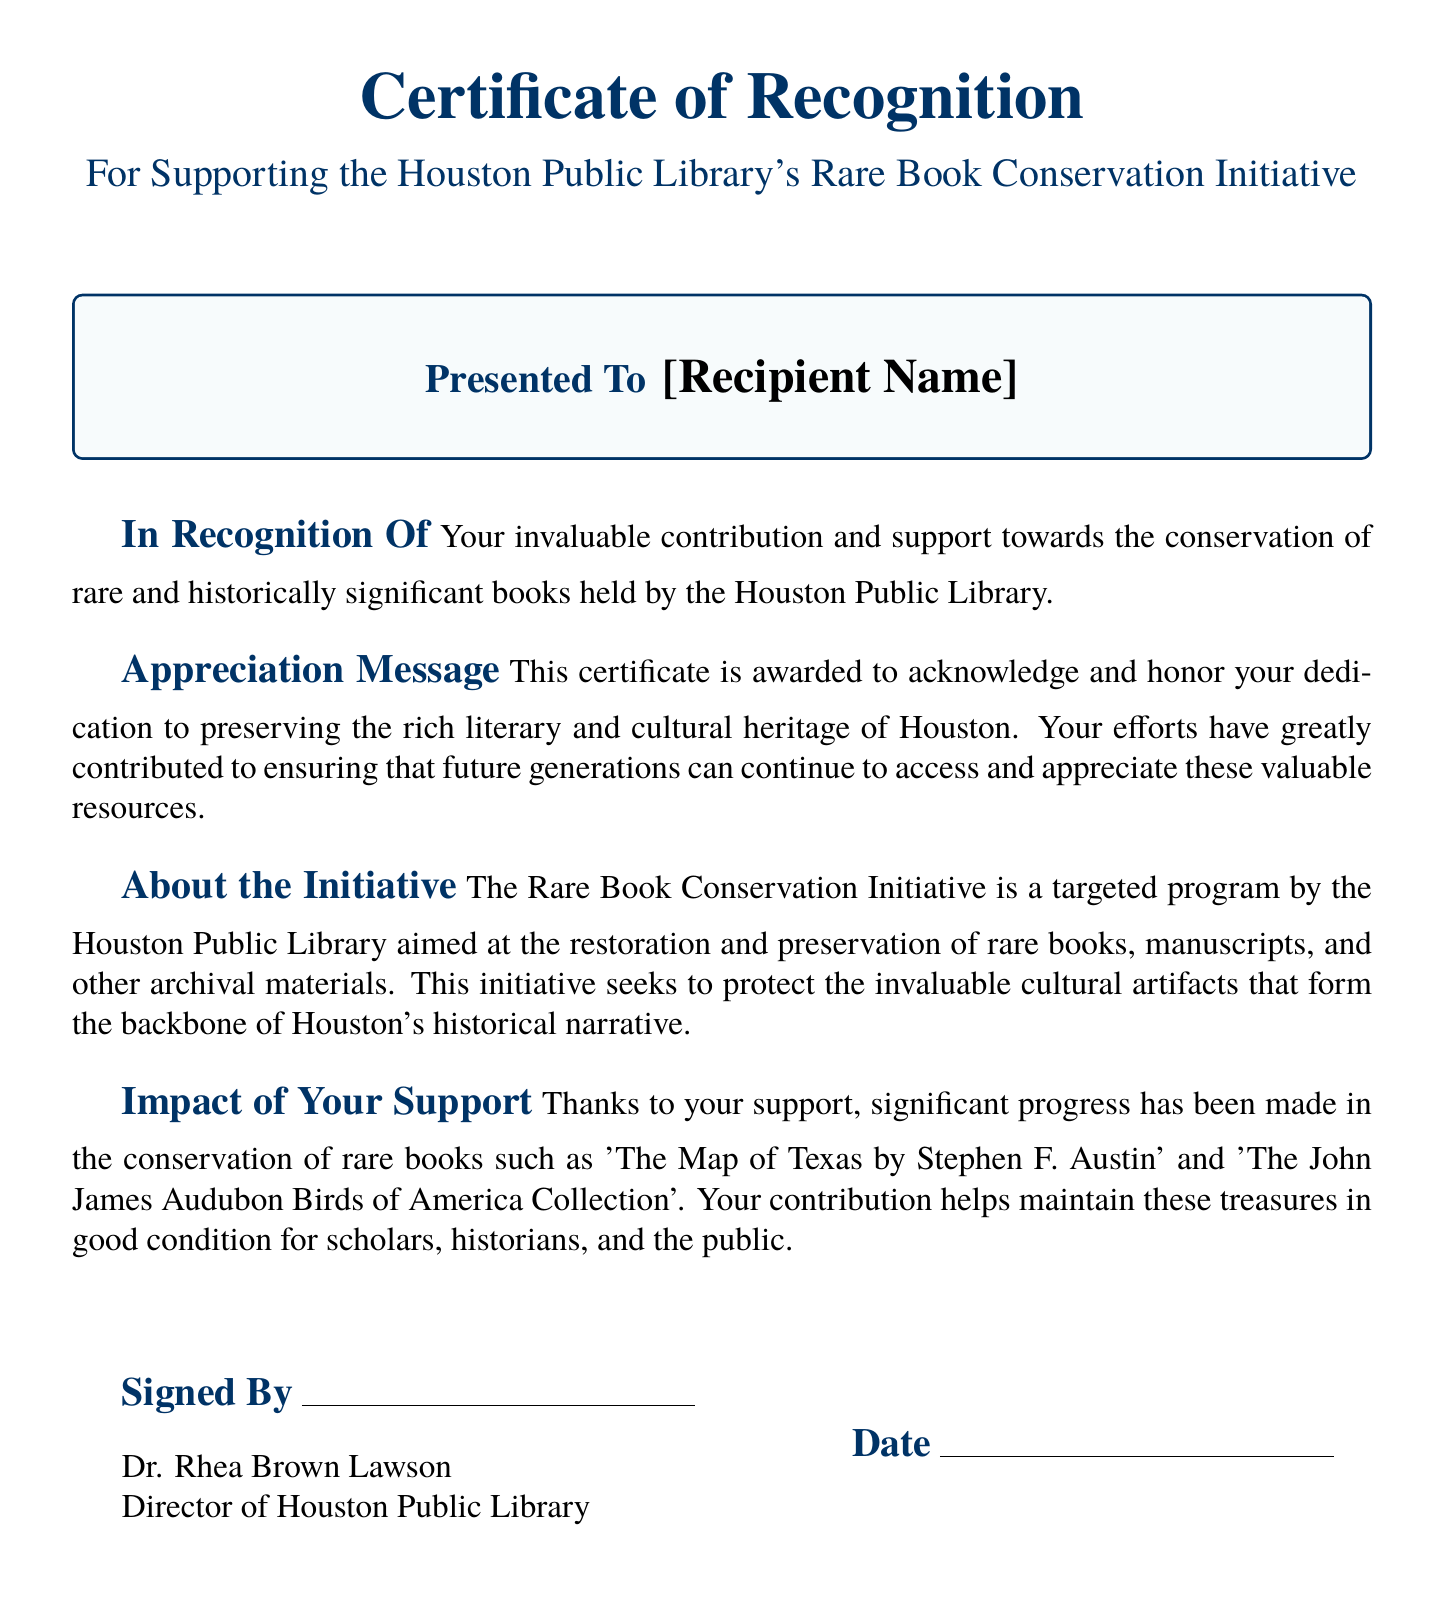what is the title of the certificate? The title of the certificate is specified in the header section of the document.
Answer: Certificate of Recognition who is the recipient of the certificate? The recipient's name is indicated within the box that is labeled "Presented To".
Answer: [Recipient Name] who signed the certificate? The signature section of the certificate names the individual who signed it.
Answer: Dr. Rhea Brown Lawson what is the purpose of the Rare Book Conservation Initiative? The purpose is described in the section titled "About the Initiative".
Answer: Restoration and preservation of rare books what is one notable book mentioned in the impact of your support section? This information is found in the section discussing the impact of the recipient's contribution.
Answer: The Map of Texas by Stephen F. Austin what is the significance of the support recognized by the certificate? The significance is explained in the "Appreciation Message" section of the document.
Answer: Preserving the rich literary and cultural heritage of Houston on what date is the certificate issued? The date section is left blank for writing in the issuance date.
Answer: [Date] 